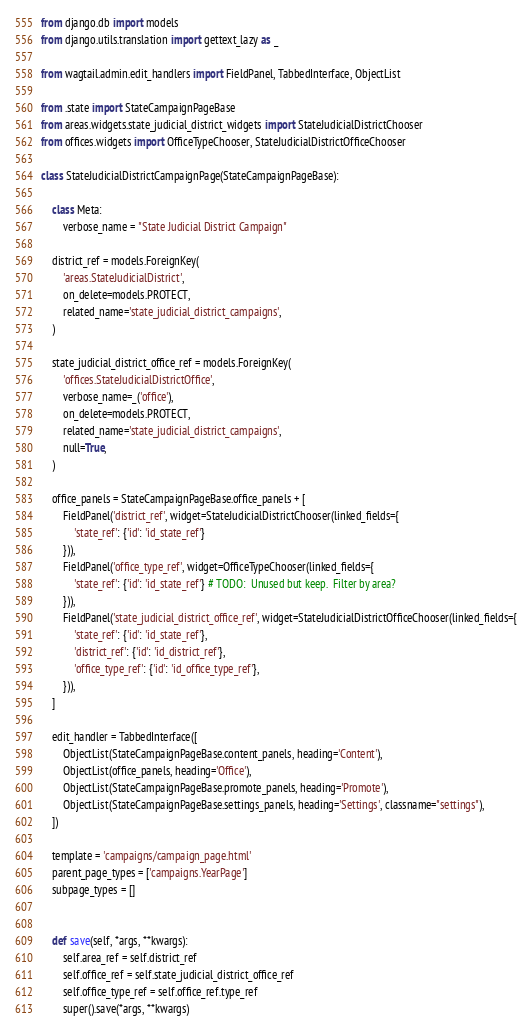<code> <loc_0><loc_0><loc_500><loc_500><_Python_>from django.db import models
from django.utils.translation import gettext_lazy as _

from wagtail.admin.edit_handlers import FieldPanel, TabbedInterface, ObjectList

from .state import StateCampaignPageBase
from areas.widgets.state_judicial_district_widgets import StateJudicialDistrictChooser
from offices.widgets import OfficeTypeChooser, StateJudicialDistrictOfficeChooser

class StateJudicialDistrictCampaignPage(StateCampaignPageBase):

    class Meta:
        verbose_name = "State Judicial District Campaign"

    district_ref = models.ForeignKey(
        'areas.StateJudicialDistrict',
        on_delete=models.PROTECT,
        related_name='state_judicial_district_campaigns',
    )

    state_judicial_district_office_ref = models.ForeignKey(
        'offices.StateJudicialDistrictOffice',
        verbose_name=_('office'),
        on_delete=models.PROTECT,
        related_name='state_judicial_district_campaigns',
        null=True,
    )

    office_panels = StateCampaignPageBase.office_panels + [
        FieldPanel('district_ref', widget=StateJudicialDistrictChooser(linked_fields={
            'state_ref': {'id': 'id_state_ref'}
        })),
        FieldPanel('office_type_ref', widget=OfficeTypeChooser(linked_fields={
            'state_ref': {'id': 'id_state_ref'} # TODO:  Unused but keep.  Filter by area?
        })),
        FieldPanel('state_judicial_district_office_ref', widget=StateJudicialDistrictOfficeChooser(linked_fields={
            'state_ref': {'id': 'id_state_ref'},
            'district_ref': {'id': 'id_district_ref'},
            'office_type_ref': {'id': 'id_office_type_ref'},
        })),
    ]

    edit_handler = TabbedInterface([
        ObjectList(StateCampaignPageBase.content_panels, heading='Content'),
        ObjectList(office_panels, heading='Office'),
        ObjectList(StateCampaignPageBase.promote_panels, heading='Promote'),
        ObjectList(StateCampaignPageBase.settings_panels, heading='Settings', classname="settings"),
    ])

    template = 'campaigns/campaign_page.html'
    parent_page_types = ['campaigns.YearPage']
    subpage_types = []
    

    def save(self, *args, **kwargs):
        self.area_ref = self.district_ref
        self.office_ref = self.state_judicial_district_office_ref
        self.office_type_ref = self.office_ref.type_ref
        super().save(*args, **kwargs)
</code> 